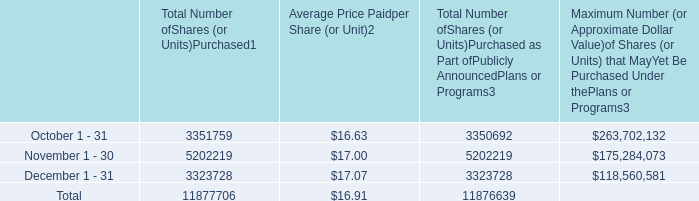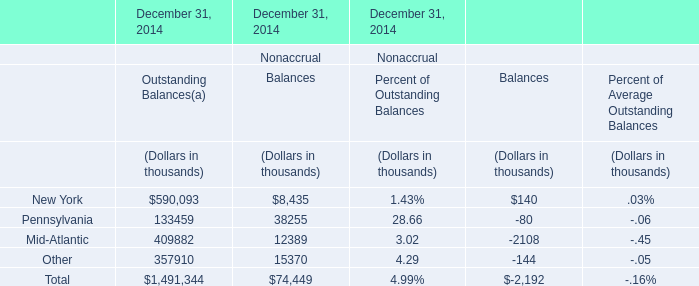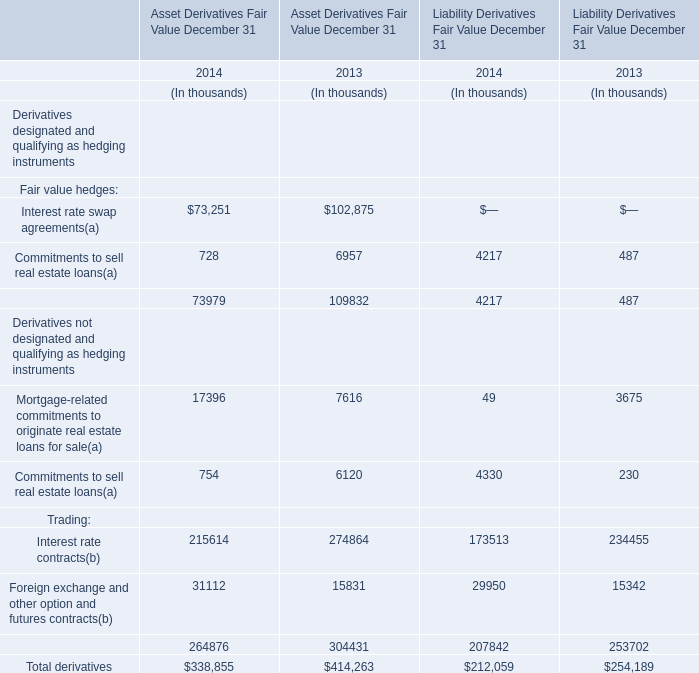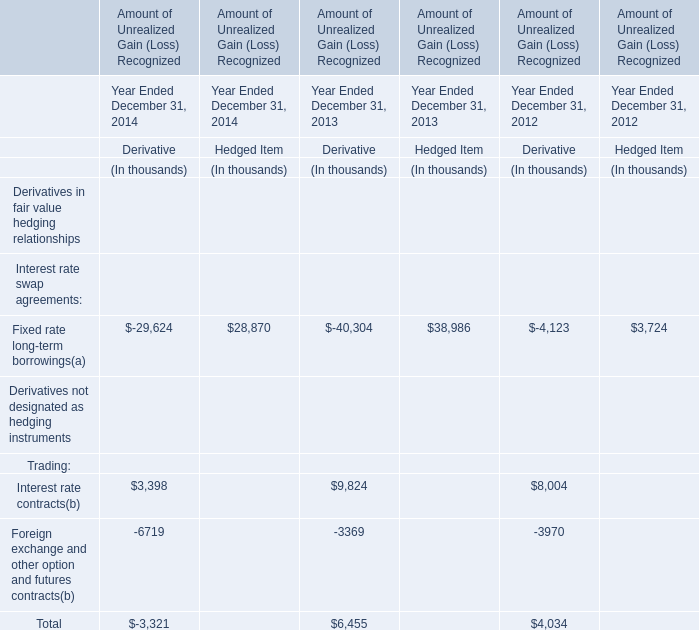Which year is Total Liability Derivatives Fair Value greater than 250000 thousand? 
Answer: 2013. 